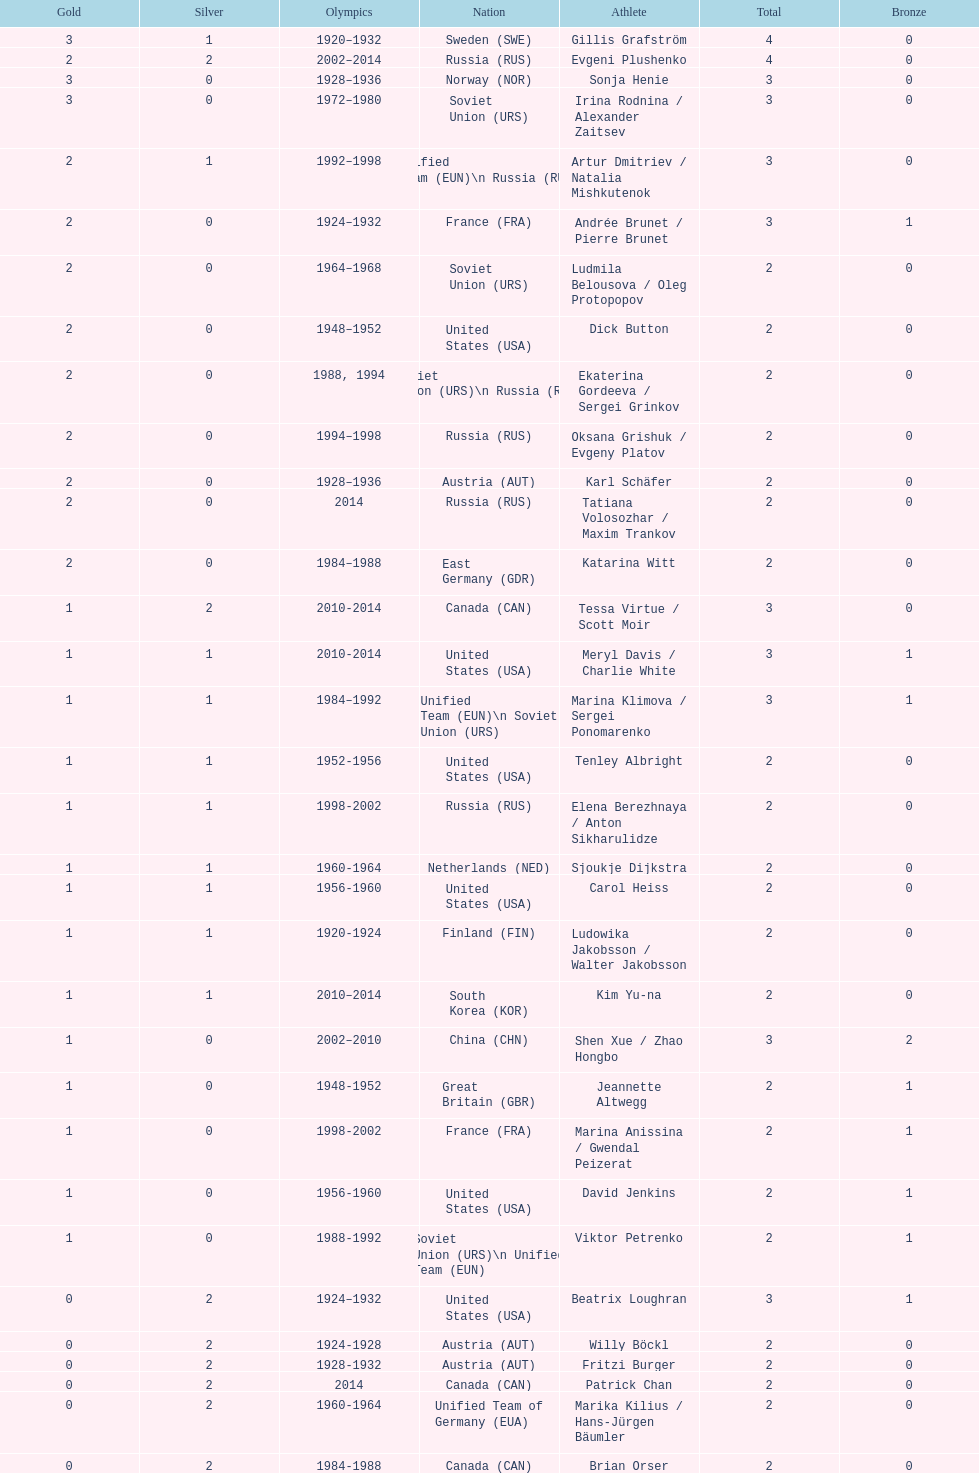How many more silver medals did gillis grafström have compared to sonja henie? 1. 